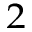Convert formula to latex. <formula><loc_0><loc_0><loc_500><loc_500>^ { 2 }</formula> 